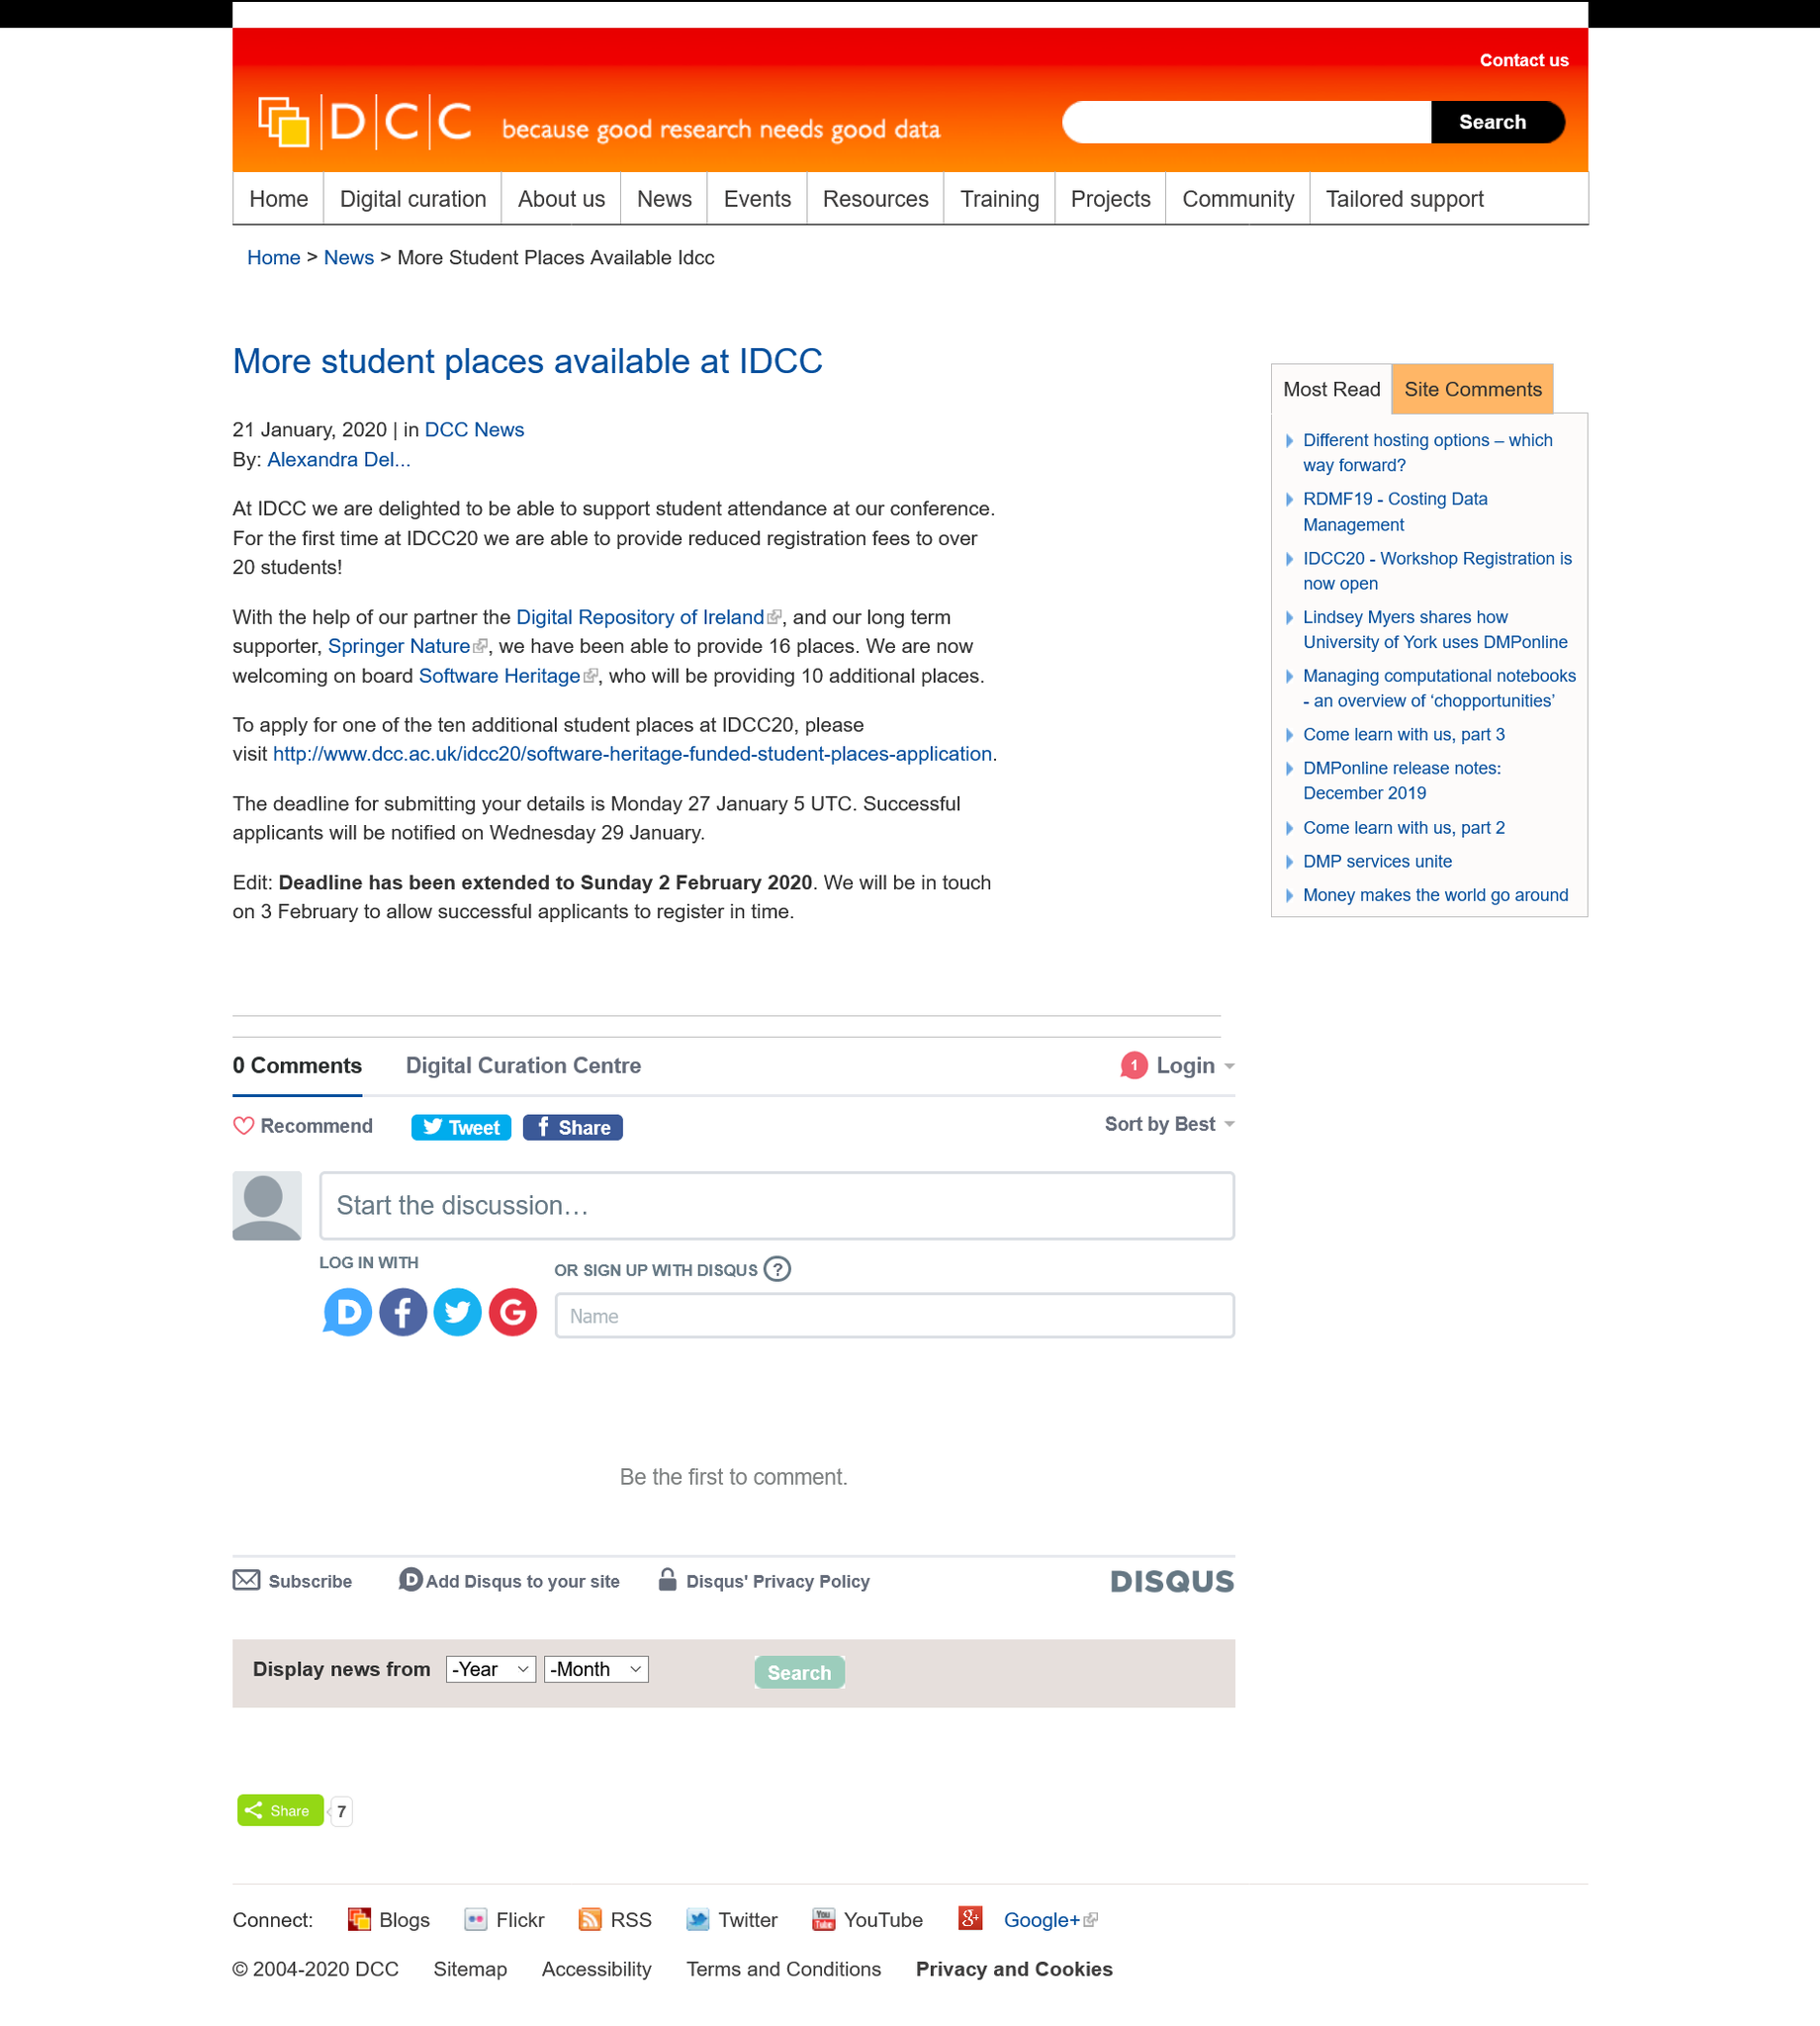List a handful of essential elements in this visual. Software Heritage is capable of providing 10 additional places. The Digital Repository of Ireland and Springer Nature can provide 16 places. IDCC20 is able to provide reduced registration fees for over 20 students. 